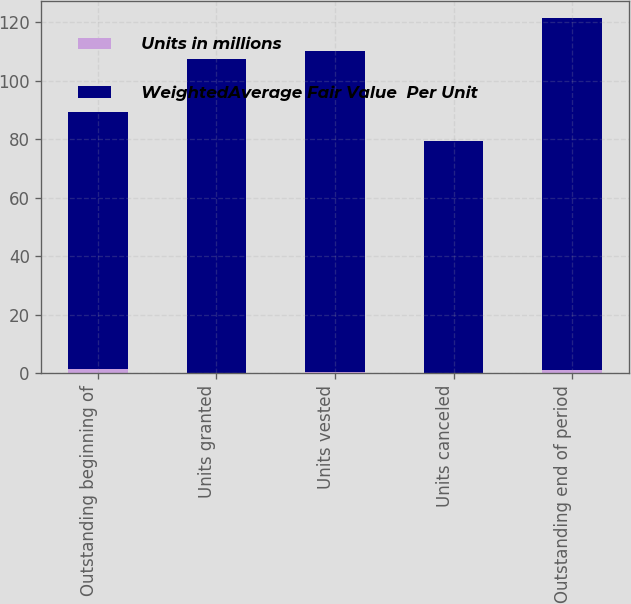Convert chart. <chart><loc_0><loc_0><loc_500><loc_500><stacked_bar_chart><ecel><fcel>Outstanding beginning of<fcel>Units granted<fcel>Units vested<fcel>Units canceled<fcel>Outstanding end of period<nl><fcel>Units in millions<fcel>1.39<fcel>0.23<fcel>0.33<fcel>0.09<fcel>1.2<nl><fcel>WeightedAverage Fair Value  Per Unit<fcel>87.88<fcel>107.05<fcel>109.84<fcel>79.32<fcel>120.13<nl></chart> 